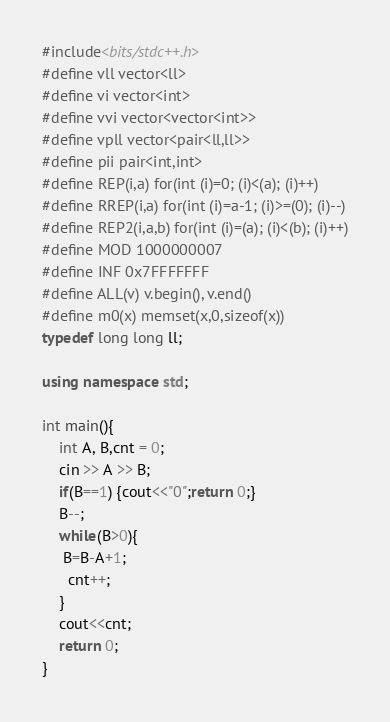<code> <loc_0><loc_0><loc_500><loc_500><_C++_>#include<bits/stdc++.h>
#define vll vector<ll>
#define vi vector<int>
#define vvi vector<vector<int>>
#define vpll vector<pair<ll,ll>>
#define pii pair<int,int>
#define REP(i,a) for(int (i)=0; (i)<(a); (i)++)
#define RREP(i,a) for(int (i)=a-1; (i)>=(0); (i)--)
#define REP2(i,a,b) for(int (i)=(a); (i)<(b); (i)++)
#define MOD 1000000007
#define INF 0x7FFFFFFF
#define ALL(v) v.begin(), v.end()  
#define m0(x) memset(x,0,sizeof(x))
typedef long long ll;

using namespace std;

int main(){
    int A, B,cnt = 0;
    cin >> A >> B;
    if(B==1) {cout<<"0";return 0;}
    B--;
    while(B>0){
     B=B-A+1;
      cnt++;
    }
    cout<<cnt;
    return 0;
}</code> 